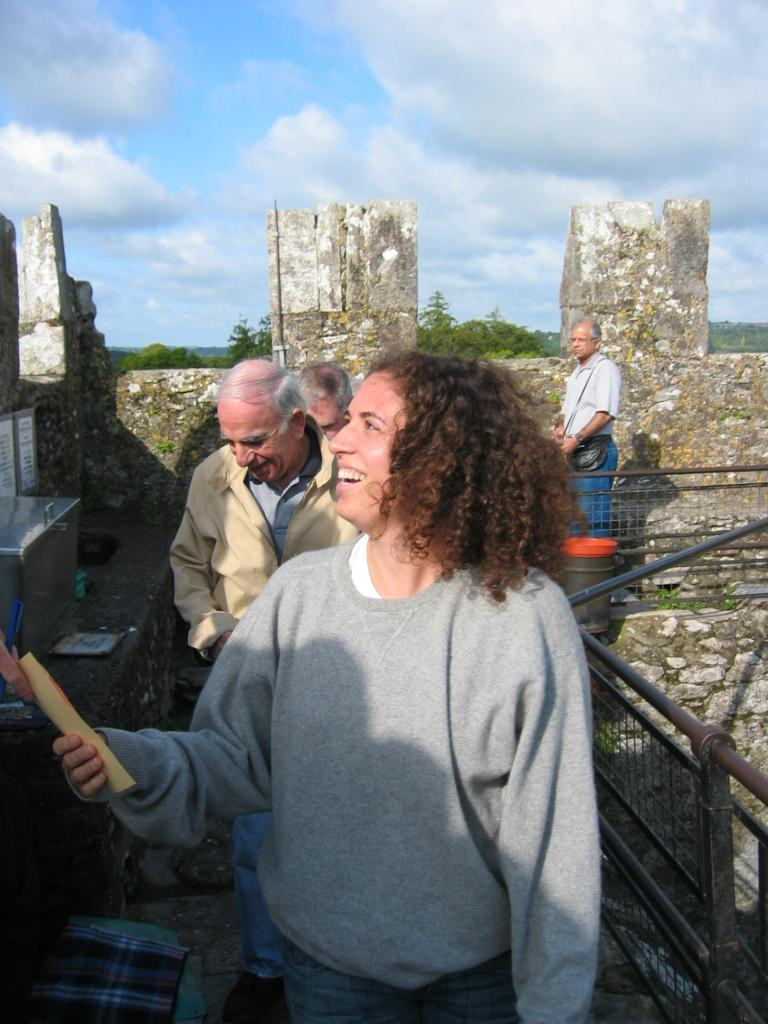How many people are in the image? There is a group of persons in the image. What are the persons in the image doing? The persons are walking on a lane. What can be seen in the background of the image? There is a tree and the sky visible in the background of the image. What is the condition of the sky in the image? The sky has clouds in it. What type of harmony is being played by the father in the image? There is no father or any musical instrument present in the image, so it is not possible to determine if any harmony is being played. 